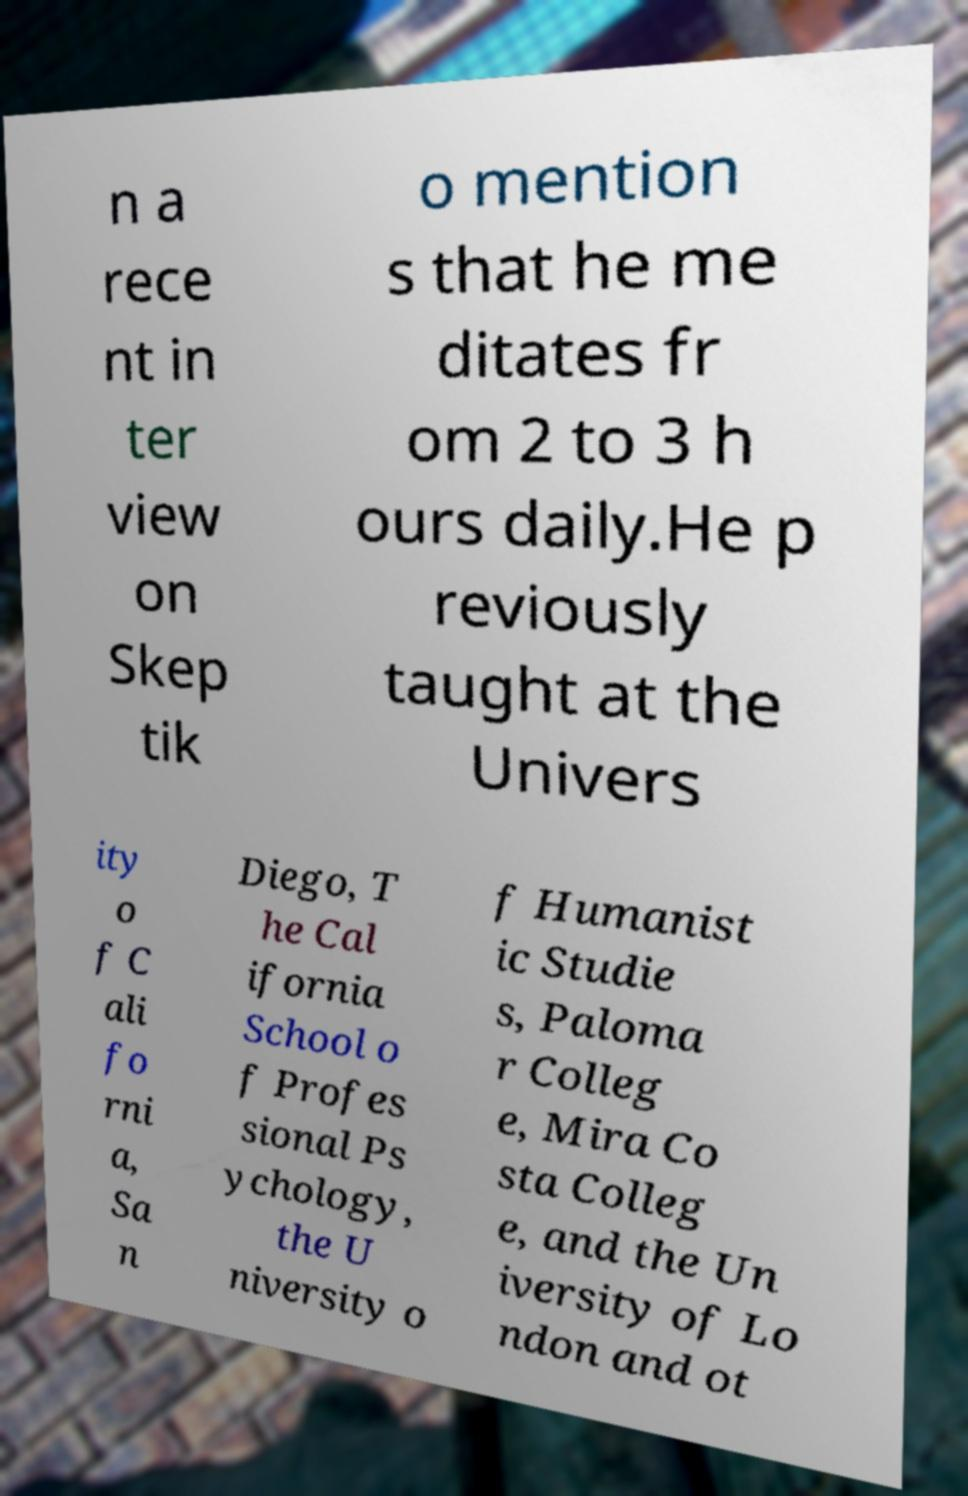Can you accurately transcribe the text from the provided image for me? n a rece nt in ter view on Skep tik o mention s that he me ditates fr om 2 to 3 h ours daily.He p reviously taught at the Univers ity o f C ali fo rni a, Sa n Diego, T he Cal ifornia School o f Profes sional Ps ychology, the U niversity o f Humanist ic Studie s, Paloma r Colleg e, Mira Co sta Colleg e, and the Un iversity of Lo ndon and ot 